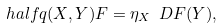<formula> <loc_0><loc_0><loc_500><loc_500>\ h a l f q ( X , Y ) F = \eta _ { X } \ D F ( Y ) ,</formula> 